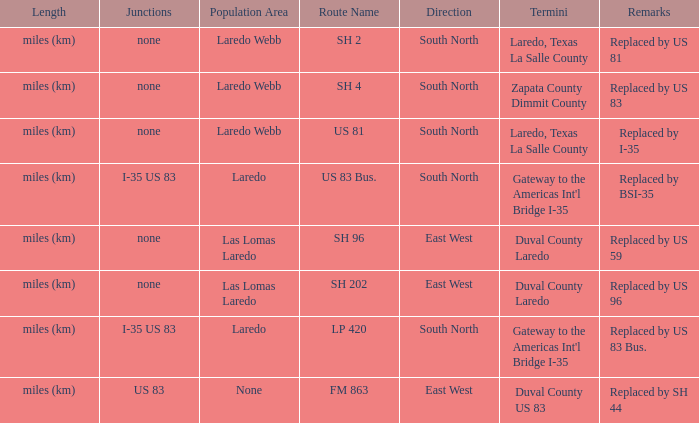How many termini are there that have "east west" listed in their direction section, "none" listed in their junction section, and have a route name of "sh 202"? 1.0. 